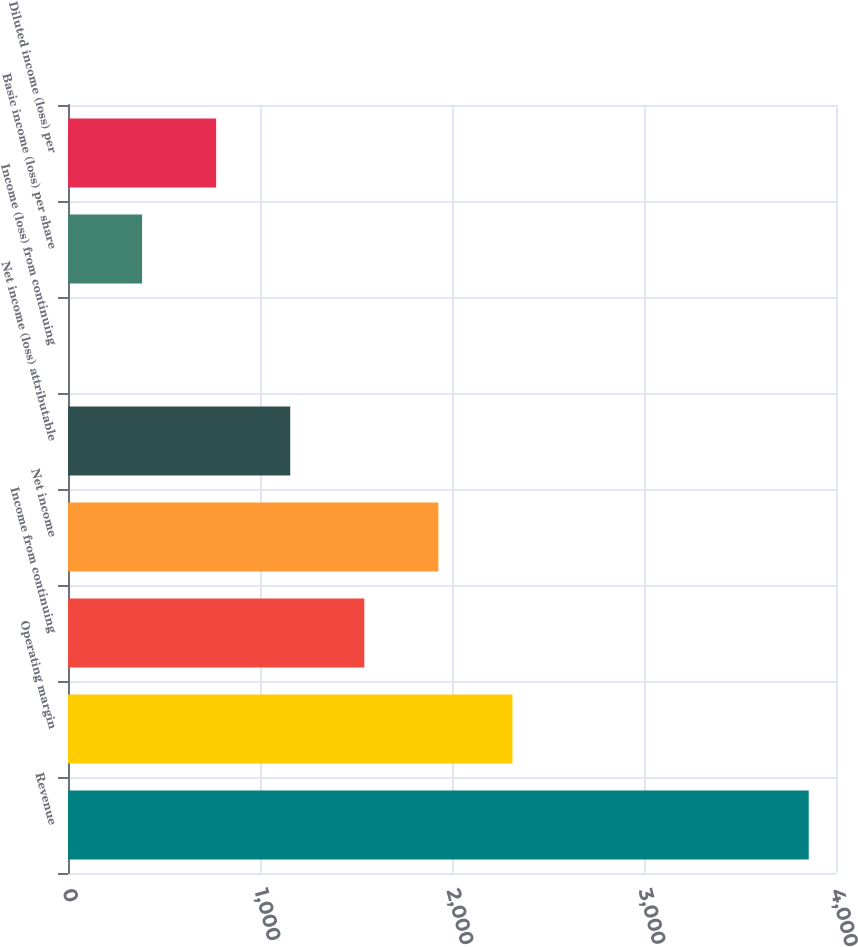<chart> <loc_0><loc_0><loc_500><loc_500><bar_chart><fcel>Revenue<fcel>Operating margin<fcel>Income from continuing<fcel>Net income<fcel>Net income (loss) attributable<fcel>Income (loss) from continuing<fcel>Basic income (loss) per share<fcel>Diluted income (loss) per<nl><fcel>3858<fcel>2314.84<fcel>1543.26<fcel>1929.05<fcel>1157.47<fcel>0.1<fcel>385.89<fcel>771.68<nl></chart> 